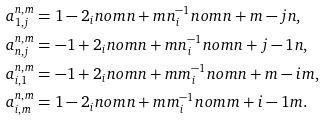Convert formula to latex. <formula><loc_0><loc_0><loc_500><loc_500>a ^ { n , m } _ { 1 , j } & = 1 - 2 _ { i } n o m { n + m } { n } ^ { - 1 } _ { i } n o m { n + m - j } { n } , \\ a ^ { n , m } _ { n , j } & = - 1 + 2 _ { i } n o m { n + m } { n } ^ { - 1 } _ { i } n o m { n + j - 1 } { n } , \\ a ^ { n , m } _ { i , 1 } & = - 1 + 2 _ { i } n o m { n + m } { m } ^ { - 1 } _ { i } n o m { n + m - i } { m } , \\ a ^ { n , m } _ { i , m } & = 1 - 2 _ { i } n o m { n + m } { m } ^ { - 1 } _ { i } n o m { m + i - 1 } { m } .</formula> 